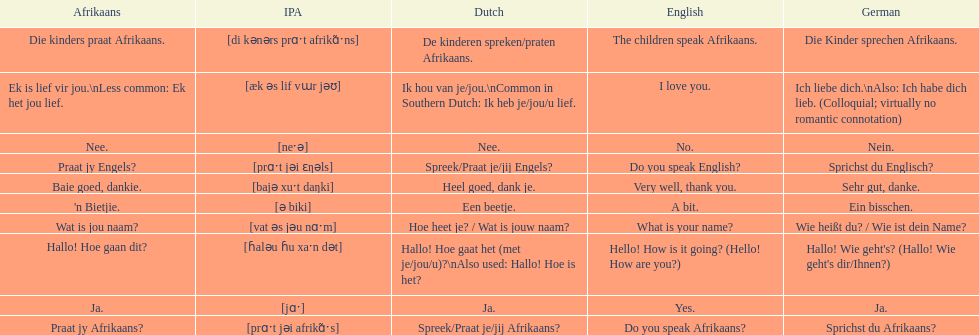How do you say 'do you speak afrikaans?' in afrikaans? Praat jy Afrikaans?. 